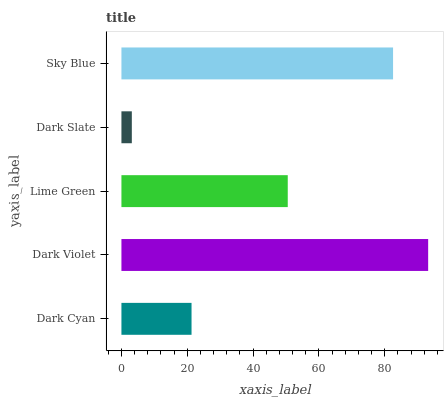Is Dark Slate the minimum?
Answer yes or no. Yes. Is Dark Violet the maximum?
Answer yes or no. Yes. Is Lime Green the minimum?
Answer yes or no. No. Is Lime Green the maximum?
Answer yes or no. No. Is Dark Violet greater than Lime Green?
Answer yes or no. Yes. Is Lime Green less than Dark Violet?
Answer yes or no. Yes. Is Lime Green greater than Dark Violet?
Answer yes or no. No. Is Dark Violet less than Lime Green?
Answer yes or no. No. Is Lime Green the high median?
Answer yes or no. Yes. Is Lime Green the low median?
Answer yes or no. Yes. Is Dark Cyan the high median?
Answer yes or no. No. Is Dark Cyan the low median?
Answer yes or no. No. 